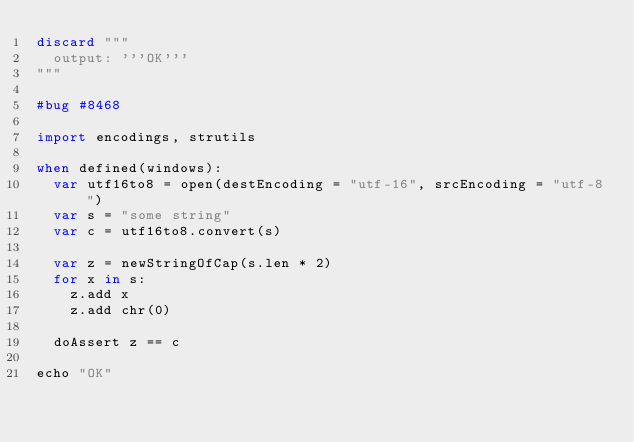<code> <loc_0><loc_0><loc_500><loc_500><_Nim_>discard """
  output: '''OK'''
"""

#bug #8468

import encodings, strutils

when defined(windows):
  var utf16to8 = open(destEncoding = "utf-16", srcEncoding = "utf-8")
  var s = "some string"
  var c = utf16to8.convert(s)

  var z = newStringOfCap(s.len * 2)
  for x in s:
    z.add x
    z.add chr(0)

  doAssert z == c

echo "OK"
</code> 